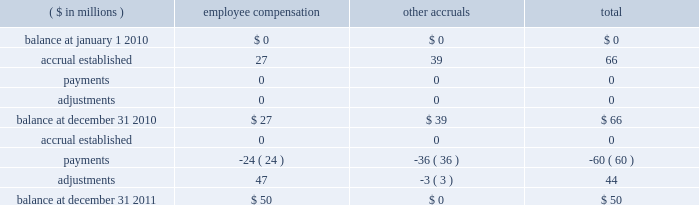Hii expects to incur higher costs to complete ships currently under construction in avondale due to anticipated reductions in productivity .
As a result , in the second quarter of 2010 , the company increased the estimates to complete lpd-23 and lpd-25 by approximately $ 210 million .
The company recognized a $ 113 million pre-tax charge to operating income for these contracts in the second quarter of 2010 .
Hii is exploring alternative uses of the avondale facility , including alternative opportunities for the workforce .
In connection with and as a result of the decision to wind down shipbuilding operations at the avondale , louisiana facility , the company began incurring and paying related employee severance and incentive compensation liabilities and expenditures , asset retirement obligation liabilities that became reasonably estimable , and amounts owed for not meeting certain requirements under its cooperative endeavor agreement with the state of louisiana .
The company anticipates that it will incur substantial other restructuring and facilities shutdown related costs , including , but not limited to , severance expense , relocation expense , and asset write-downs related to the avondale facilities .
These costs are expected to be allowable expenses under government accounting standards and thus should be recoverable in future years 2019 overhead costs .
These future costs could approximate $ 271 million , based on management 2019s current estimate .
Such costs should be recoverable under existing flexibly priced contracts or future negotiated contracts in accordance with federal acquisition regulation ( 201cfar 201d ) provisions relating to the treatment of restructuring and shutdown related costs .
The company is currently in discussions with the u.s .
Navy regarding its cost submission to support the recoverability of these costs under the far and applicable contracts , and this submission is subject to review and acceptance by the u.s .
Navy .
The defense contract audit agency ( 201cdcaa 201d ) , a dod agency , prepared an initial audit report on the company 2019s cost proposal for restructuring and shutdown related costs of $ 310 million , which stated that the proposal was not adequately supported for the dcaa to reach a conclusion and questioned approximately $ 25 million , or 8% ( 8 % ) , of the costs submitted by the company .
Accordingly , the dcaa did not accept the proposal as submitted .
The company has submitted a revised proposal to address the concerns of the dcaa and to reflect a revised estimated total cost of $ 271 million .
Should the company 2019s revised proposal be challenged by the u.s .
Navy , the company would likely pursue prescribed dispute resolution alternatives to resolve the challenge .
That process , however , would create uncertainty as to the timing and eventual allowability of the costs related to the wind down of the avondale facility .
Ultimately , the company anticipates these discussions with the u.s .
Navy will result in an agreement that is substantially in accordance with management 2019s cost recovery expectations .
Accordingly , hii has treated these costs as allowable costs in determining the earnings performance on its contracts in process .
The actual restructuring expenses related to the wind down may be greater than the company 2019s current estimate , and any inability to recover such costs could result in a material effect on the company 2019s consolidated financial position , results of operations or cash flows .
The company also evaluated the effect that the wind down of the avondale facilities might have on the benefit plans in which hii employees participate .
Hii determined that the potential impact of a curtailment in these plans was not material to its consolidated financial position , results of operations or cash flows .
The table below summarizes the company 2019s liability for restructuring and shutdown related costs associated with winding down the avondale facility .
As of december 31 , 2011 and 2010 , these costs are comprised primarily of employee severance and retention and incentive bonuses .
These amounts were capitalized in inventoried costs , and will be recognized as expenses in cost of product sales beginning in 2014 .
( $ in millions ) employee compensation other accruals total .

What is the net change in employee compensation during 2011? 
Computations: (50 - 27)
Answer: 23.0. Hii expects to incur higher costs to complete ships currently under construction in avondale due to anticipated reductions in productivity .
As a result , in the second quarter of 2010 , the company increased the estimates to complete lpd-23 and lpd-25 by approximately $ 210 million .
The company recognized a $ 113 million pre-tax charge to operating income for these contracts in the second quarter of 2010 .
Hii is exploring alternative uses of the avondale facility , including alternative opportunities for the workforce .
In connection with and as a result of the decision to wind down shipbuilding operations at the avondale , louisiana facility , the company began incurring and paying related employee severance and incentive compensation liabilities and expenditures , asset retirement obligation liabilities that became reasonably estimable , and amounts owed for not meeting certain requirements under its cooperative endeavor agreement with the state of louisiana .
The company anticipates that it will incur substantial other restructuring and facilities shutdown related costs , including , but not limited to , severance expense , relocation expense , and asset write-downs related to the avondale facilities .
These costs are expected to be allowable expenses under government accounting standards and thus should be recoverable in future years 2019 overhead costs .
These future costs could approximate $ 271 million , based on management 2019s current estimate .
Such costs should be recoverable under existing flexibly priced contracts or future negotiated contracts in accordance with federal acquisition regulation ( 201cfar 201d ) provisions relating to the treatment of restructuring and shutdown related costs .
The company is currently in discussions with the u.s .
Navy regarding its cost submission to support the recoverability of these costs under the far and applicable contracts , and this submission is subject to review and acceptance by the u.s .
Navy .
The defense contract audit agency ( 201cdcaa 201d ) , a dod agency , prepared an initial audit report on the company 2019s cost proposal for restructuring and shutdown related costs of $ 310 million , which stated that the proposal was not adequately supported for the dcaa to reach a conclusion and questioned approximately $ 25 million , or 8% ( 8 % ) , of the costs submitted by the company .
Accordingly , the dcaa did not accept the proposal as submitted .
The company has submitted a revised proposal to address the concerns of the dcaa and to reflect a revised estimated total cost of $ 271 million .
Should the company 2019s revised proposal be challenged by the u.s .
Navy , the company would likely pursue prescribed dispute resolution alternatives to resolve the challenge .
That process , however , would create uncertainty as to the timing and eventual allowability of the costs related to the wind down of the avondale facility .
Ultimately , the company anticipates these discussions with the u.s .
Navy will result in an agreement that is substantially in accordance with management 2019s cost recovery expectations .
Accordingly , hii has treated these costs as allowable costs in determining the earnings performance on its contracts in process .
The actual restructuring expenses related to the wind down may be greater than the company 2019s current estimate , and any inability to recover such costs could result in a material effect on the company 2019s consolidated financial position , results of operations or cash flows .
The company also evaluated the effect that the wind down of the avondale facilities might have on the benefit plans in which hii employees participate .
Hii determined that the potential impact of a curtailment in these plans was not material to its consolidated financial position , results of operations or cash flows .
The table below summarizes the company 2019s liability for restructuring and shutdown related costs associated with winding down the avondale facility .
As of december 31 , 2011 and 2010 , these costs are comprised primarily of employee severance and retention and incentive bonuses .
These amounts were capitalized in inventoried costs , and will be recognized as expenses in cost of product sales beginning in 2014 .
( $ in millions ) employee compensation other accruals total .

What was the percentage reduction in the shut down related costs as presented to the dod? 
Rationale: the percentage change is the change from the current to most recent divide by the most recent
Computations: ((271 - 310) / 310)
Answer: -0.12581. Hii expects to incur higher costs to complete ships currently under construction in avondale due to anticipated reductions in productivity .
As a result , in the second quarter of 2010 , the company increased the estimates to complete lpd-23 and lpd-25 by approximately $ 210 million .
The company recognized a $ 113 million pre-tax charge to operating income for these contracts in the second quarter of 2010 .
Hii is exploring alternative uses of the avondale facility , including alternative opportunities for the workforce .
In connection with and as a result of the decision to wind down shipbuilding operations at the avondale , louisiana facility , the company began incurring and paying related employee severance and incentive compensation liabilities and expenditures , asset retirement obligation liabilities that became reasonably estimable , and amounts owed for not meeting certain requirements under its cooperative endeavor agreement with the state of louisiana .
The company anticipates that it will incur substantial other restructuring and facilities shutdown related costs , including , but not limited to , severance expense , relocation expense , and asset write-downs related to the avondale facilities .
These costs are expected to be allowable expenses under government accounting standards and thus should be recoverable in future years 2019 overhead costs .
These future costs could approximate $ 271 million , based on management 2019s current estimate .
Such costs should be recoverable under existing flexibly priced contracts or future negotiated contracts in accordance with federal acquisition regulation ( 201cfar 201d ) provisions relating to the treatment of restructuring and shutdown related costs .
The company is currently in discussions with the u.s .
Navy regarding its cost submission to support the recoverability of these costs under the far and applicable contracts , and this submission is subject to review and acceptance by the u.s .
Navy .
The defense contract audit agency ( 201cdcaa 201d ) , a dod agency , prepared an initial audit report on the company 2019s cost proposal for restructuring and shutdown related costs of $ 310 million , which stated that the proposal was not adequately supported for the dcaa to reach a conclusion and questioned approximately $ 25 million , or 8% ( 8 % ) , of the costs submitted by the company .
Accordingly , the dcaa did not accept the proposal as submitted .
The company has submitted a revised proposal to address the concerns of the dcaa and to reflect a revised estimated total cost of $ 271 million .
Should the company 2019s revised proposal be challenged by the u.s .
Navy , the company would likely pursue prescribed dispute resolution alternatives to resolve the challenge .
That process , however , would create uncertainty as to the timing and eventual allowability of the costs related to the wind down of the avondale facility .
Ultimately , the company anticipates these discussions with the u.s .
Navy will result in an agreement that is substantially in accordance with management 2019s cost recovery expectations .
Accordingly , hii has treated these costs as allowable costs in determining the earnings performance on its contracts in process .
The actual restructuring expenses related to the wind down may be greater than the company 2019s current estimate , and any inability to recover such costs could result in a material effect on the company 2019s consolidated financial position , results of operations or cash flows .
The company also evaluated the effect that the wind down of the avondale facilities might have on the benefit plans in which hii employees participate .
Hii determined that the potential impact of a curtailment in these plans was not material to its consolidated financial position , results of operations or cash flows .
The table below summarizes the company 2019s liability for restructuring and shutdown related costs associated with winding down the avondale facility .
As of december 31 , 2011 and 2010 , these costs are comprised primarily of employee severance and retention and incentive bonuses .
These amounts were capitalized in inventoried costs , and will be recognized as expenses in cost of product sales beginning in 2014 .
( $ in millions ) employee compensation other accruals total .

What is the net change in employee compensation during 2010? 
Computations: (27 - 0)
Answer: 27.0. 